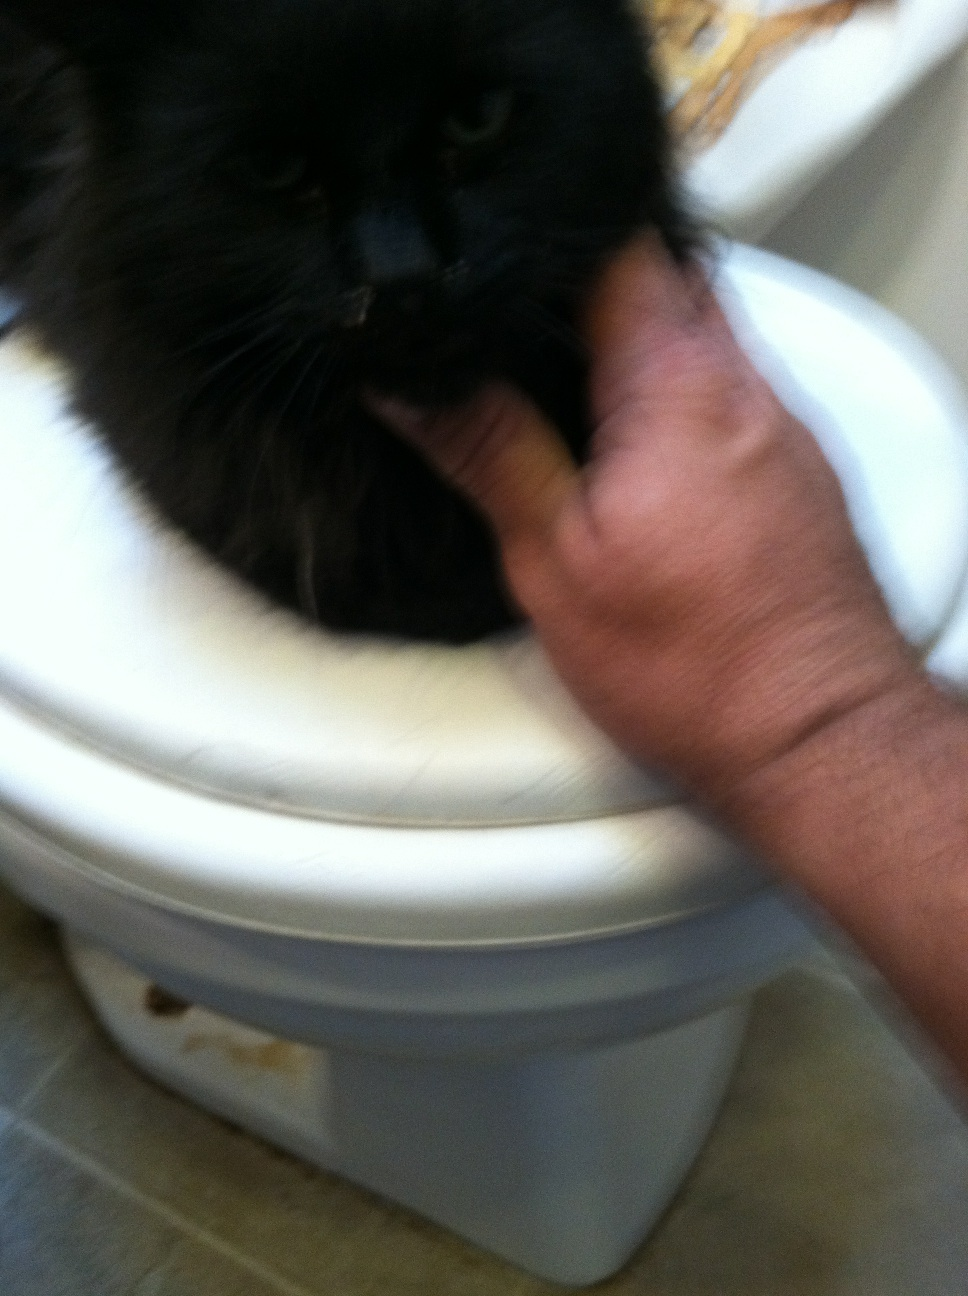What can you tell me about the breed of this cat? While the image is blurry, the cat appears to have long fur, which may suggest it is a breed with a longer coat, such as a Maine Coon, Persian, or a Norwegian Forest Cat, among others. However, without seeing more defining features and considering the mix of feline genetics, especially in strays, it's hard to definitively assign a breed. 